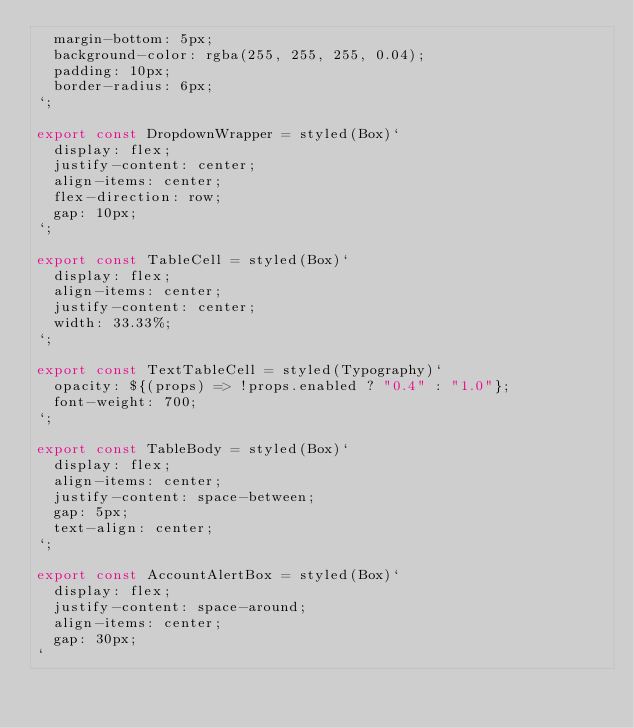<code> <loc_0><loc_0><loc_500><loc_500><_JavaScript_>  margin-bottom: 5px;
  background-color: rgba(255, 255, 255, 0.04);
  padding: 10px;
  border-radius: 6px;
`;

export const DropdownWrapper = styled(Box)`
  display: flex;
  justify-content: center;
  align-items: center;
  flex-direction: row;
  gap: 10px;
`;

export const TableCell = styled(Box)`
  display: flex;
  align-items: center;
  justify-content: center;
  width: 33.33%;
`;

export const TextTableCell = styled(Typography)`
  opacity: ${(props) => !props.enabled ? "0.4" : "1.0"};
  font-weight: 700;
`;

export const TableBody = styled(Box)`
  display: flex;
  align-items: center;
  justify-content: space-between;
  gap: 5px;
  text-align: center;
`;

export const AccountAlertBox = styled(Box)`
  display: flex;
  justify-content: space-around;
  align-items: center;
  gap: 30px;
`
</code> 